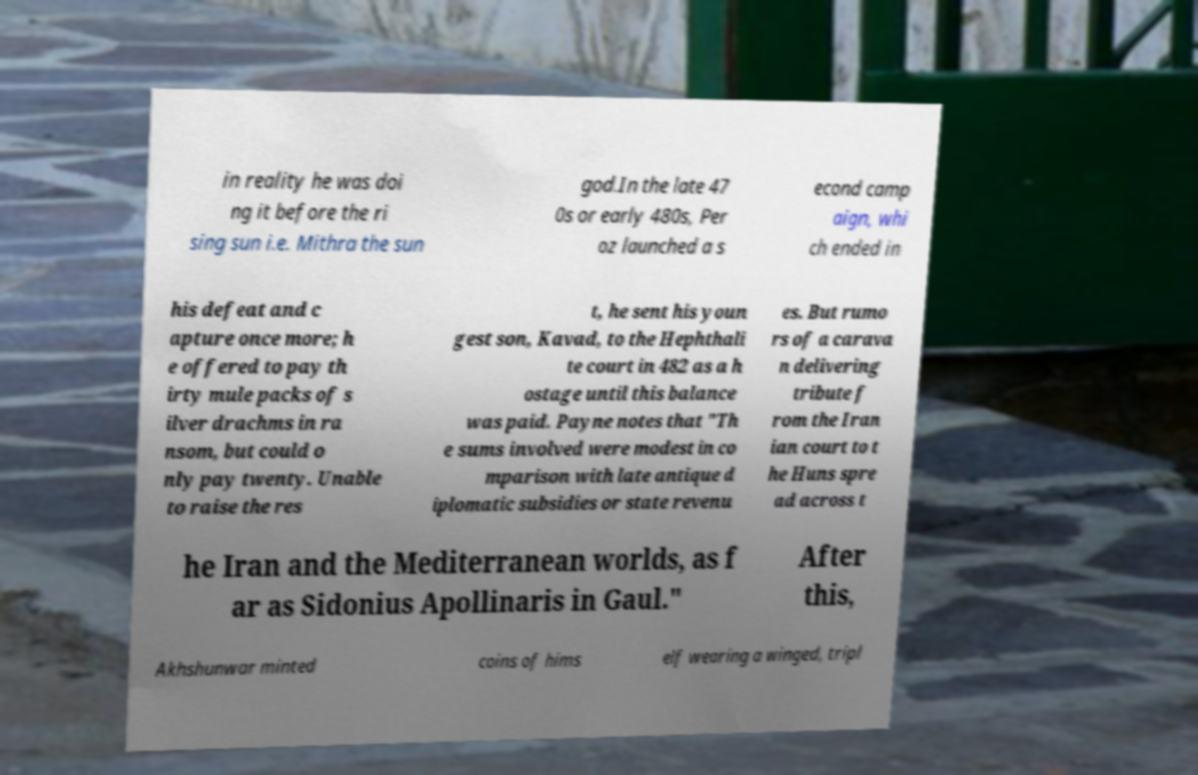Can you read and provide the text displayed in the image?This photo seems to have some interesting text. Can you extract and type it out for me? in reality he was doi ng it before the ri sing sun i.e. Mithra the sun god.In the late 47 0s or early 480s, Per oz launched a s econd camp aign, whi ch ended in his defeat and c apture once more; h e offered to pay th irty mule packs of s ilver drachms in ra nsom, but could o nly pay twenty. Unable to raise the res t, he sent his youn gest son, Kavad, to the Hephthali te court in 482 as a h ostage until this balance was paid. Payne notes that "Th e sums involved were modest in co mparison with late antique d iplomatic subsidies or state revenu es. But rumo rs of a carava n delivering tribute f rom the Iran ian court to t he Huns spre ad across t he Iran and the Mediterranean worlds, as f ar as Sidonius Apollinaris in Gaul." After this, Akhshunwar minted coins of hims elf wearing a winged, tripl 